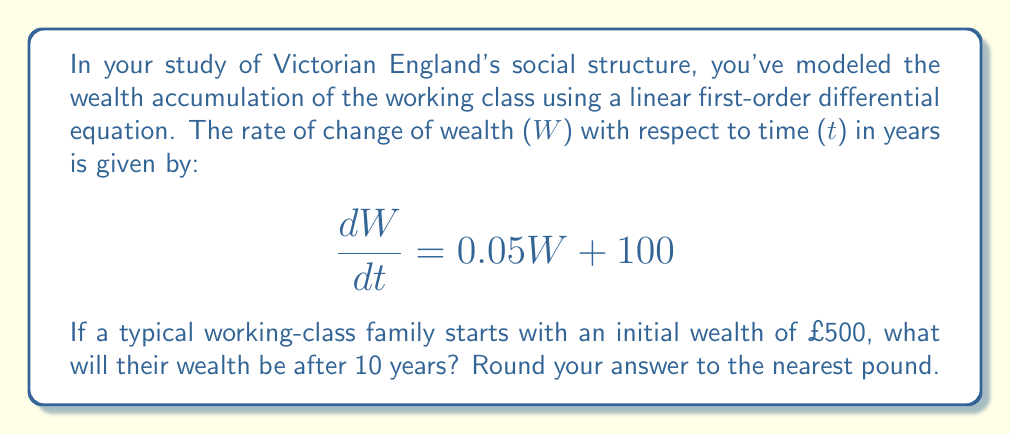Could you help me with this problem? To solve this problem, we need to follow these steps:

1) The given differential equation is of the form:
   $$\frac{dW}{dt} = aW + b$$
   where $a = 0.05$ and $b = 100$

2) The general solution for this type of equation is:
   $$W(t) = Ce^{at} - \frac{b}{a}$$
   where $C$ is a constant we need to determine from the initial conditions.

3) Substituting our values:
   $$W(t) = Ce^{0.05t} - \frac{100}{0.05} = Ce^{0.05t} - 2000$$

4) We're given that $W(0) = 500$, so let's use this to find $C$:
   $$500 = Ce^{0.05(0)} - 2000$$
   $$500 = C - 2000$$
   $$C = 2500$$

5) Now our particular solution is:
   $$W(t) = 2500e^{0.05t} - 2000$$

6) To find the wealth after 10 years, we calculate $W(10)$:
   $$W(10) = 2500e^{0.05(10)} - 2000$$
   $$= 2500e^{0.5} - 2000$$
   $$\approx 2500(1.6487) - 2000$$
   $$\approx 4121.75 - 2000$$
   $$\approx 2121.75$$

7) Rounding to the nearest pound:
   $$W(10) \approx £2122$$
Answer: £2122 